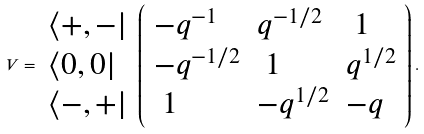Convert formula to latex. <formula><loc_0><loc_0><loc_500><loc_500>V = \begin{array} { l } \left \langle + , - \right | \\ \left \langle 0 , 0 \right | \\ \left \langle - , + \right | \end{array} \left ( \begin{array} { l l l } - q ^ { - 1 } & q ^ { - 1 / 2 } & \ 1 \\ - q ^ { - 1 / 2 } & \ 1 & q ^ { 1 / 2 } \\ \ 1 & - q ^ { 1 / 2 } & - q \end{array} \right ) .</formula> 